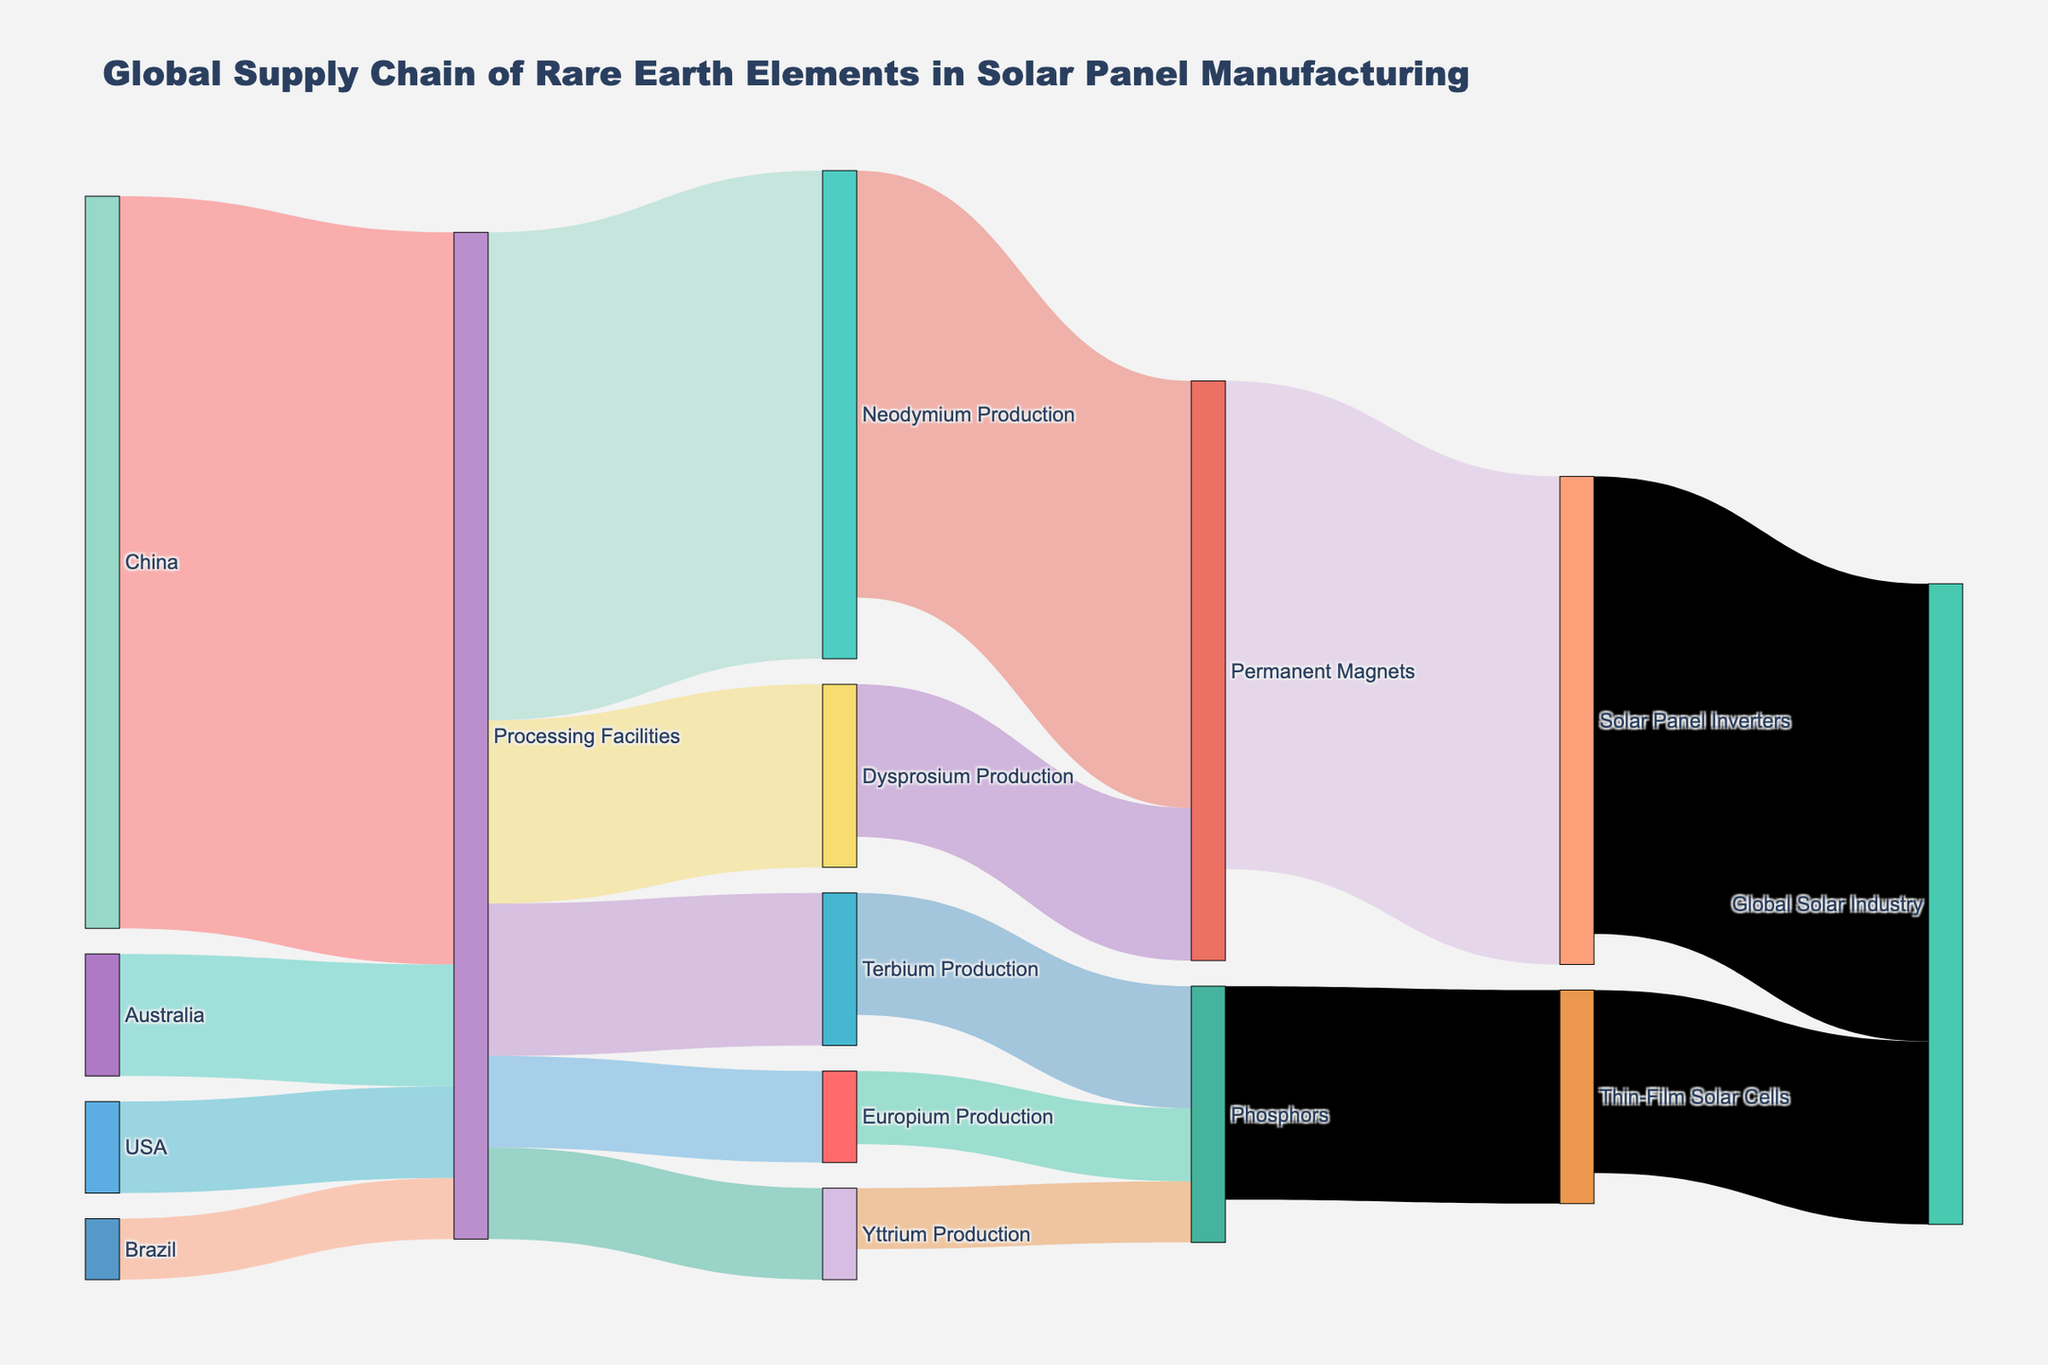Which country supplies the most material to processing facilities? Looking into the left part of the Sankey Diagram, we see four countries that supply materials to processing facilities: China, Australia, USA, and Brazil. China has the largest flow, represented by the widest band, indicating the highest value.
Answer: China What percentage of materials processed go to Neodymium Production? Summing up all materials flowing into processing facilities (120000 from China + 20000 from Australia + 15000 from USA + 10000 from Brazil = 165000). Then, the flow to Neodymium Production is 80000, so the percentage is (80000 / 165000) * 100 = 48.48%.
Answer: 48.48% Which production facility contributes the most to Permanent Magnets? Among the production facilities, Neodymium Production and Dysprosium Production supply materials to Permanent Magnets. Neodymium contributes 70000 and Dysprosium 25000. Neodymium contribution is higher.
Answer: Neodymium Production How many pathways lead to the Global Solar Industry? Observing the diagram, we see two pathways: one from Solar Panel Inverters and the other from Thin-Film Solar Cells. Both merge into the Global Solar Industry.
Answer: 2 Which final product receives more resources: Solar Panel Inverters or Thin-Film Solar Cells? From the Sankey Diagram, Permanent Magnets flow into Solar Panel Inverters with a value of 80000, and Phosphors flow into Thin-Film Solar Cells with a value of 35000. Solar Panel Inverters receive more resources.
Answer: Solar Panel Inverters What is the total value flowing into Phosphors production? Observing all inputs to Phosphors: Terbium Production (20000), Europium Production (12000), and Yttrium Production (10000). Adding them together, 20000 + 12000 + 10000 = 42000.
Answer: 42000 Which product derived from processing facilities has the smallest value? Analyzing the outputs from Processing Facilities, the values are 80000 (Neodymium), 30000 (Dysprosium), 25000 (Terbium), 15000 (Europium), and 15000 (Yttrium). Both Europium and Yttrium have the smallest values, both being equal.
Answer: Europium Production and Yttrium Production What fraction of Neodymium production is used in Solar Panel Inverters? Neodymium Production has a total value of 80000. Looking at the flow to Permanent Magnets, which are then used for Solar Panel Inverters, 70000 out of 80000 goes to Permanent Magnets and then flows into Solar Panel Inverters directly. The fraction is 70000 / 80000 = 0.875.
Answer: 0.875 How many countries supply materials to the processing facilities? From the left side of the diagram, the countries listed are China, Australia, USA, and Brazil. Counting the distinct entities, we have 4 countries.
Answer: 4 Which product has a higher value flowing directly into the Global Solar Industry: Solar Panel Inverters or Thin-Film Solar Cells? Observing the terminal flows into the Global Solar Industry, 75000 comes from Solar Panel Inverters and 30000 comes from Thin-Film Solar Cells. Solar Panel Inverters have a higher value.
Answer: Solar Panel Inverters 